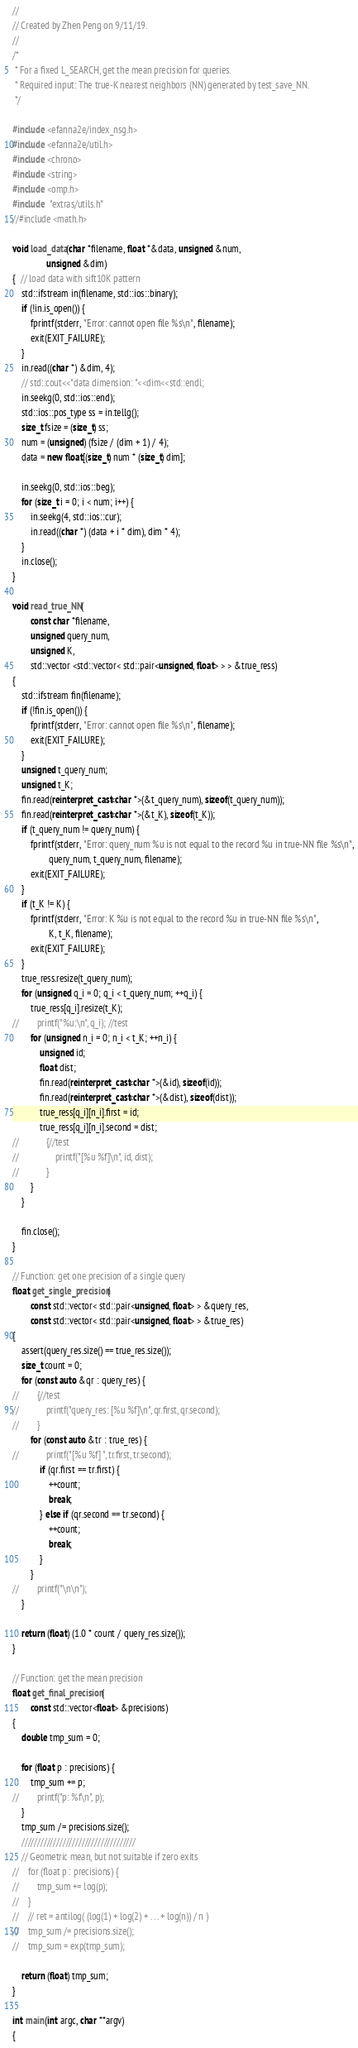<code> <loc_0><loc_0><loc_500><loc_500><_C++_>//
// Created by Zhen Peng on 9/11/19.
//
/*
 * For a fixed L_SEARCH, get the mean precision for queries.
 * Required input: The true-K nearest neighbors (NN) generated by test_save_NN.
 */

#include <efanna2e/index_nsg.h>
#include <efanna2e/util.h>
#include <chrono>
#include <string>
#include <omp.h>
#include  "extras/utils.h"
//#include <math.h>

void load_data(char *filename, float *&data, unsigned &num,
               unsigned &dim)
{  // load data with sift10K pattern
    std::ifstream in(filename, std::ios::binary);
    if (!in.is_open()) {
        fprintf(stderr, "Error: cannot open file %s\n", filename);
        exit(EXIT_FAILURE);
    }
    in.read((char *) &dim, 4);
    // std::cout<<"data dimension: "<<dim<<std::endl;
    in.seekg(0, std::ios::end);
    std::ios::pos_type ss = in.tellg();
    size_t fsize = (size_t) ss;
    num = (unsigned) (fsize / (dim + 1) / 4);
    data = new float[(size_t) num * (size_t) dim];

    in.seekg(0, std::ios::beg);
    for (size_t i = 0; i < num; i++) {
        in.seekg(4, std::ios::cur);
        in.read((char *) (data + i * dim), dim * 4);
    }
    in.close();
}

void read_true_NN(
        const char *filename,
        unsigned query_num,
        unsigned K,
        std::vector <std::vector< std::pair<unsigned, float> > > &true_ress)
{
    std::ifstream fin(filename);
    if (!fin.is_open()) {
        fprintf(stderr, "Error: cannot open file %s\n", filename);
        exit(EXIT_FAILURE);
    }
    unsigned t_query_num;
    unsigned t_K;
    fin.read(reinterpret_cast<char *>(&t_query_num), sizeof(t_query_num));
    fin.read(reinterpret_cast<char *>(&t_K), sizeof(t_K));
    if (t_query_num != query_num) {
        fprintf(stderr, "Error: query_num %u is not equal to the record %u in true-NN file %s\n",
                query_num, t_query_num, filename);
        exit(EXIT_FAILURE);
    }
    if (t_K != K) {
        fprintf(stderr, "Error: K %u is not equal to the record %u in true-NN file %s\n",
                K, t_K, filename);
        exit(EXIT_FAILURE);
    }
    true_ress.resize(t_query_num);
    for (unsigned q_i = 0; q_i < t_query_num; ++q_i) {
        true_ress[q_i].resize(t_K);
//        printf("%u:\n", q_i); //test
        for (unsigned n_i = 0; n_i < t_K; ++n_i) {
            unsigned id;
            float dist;
            fin.read(reinterpret_cast<char *>(&id), sizeof(id));
            fin.read(reinterpret_cast<char *>(&dist), sizeof(dist));
            true_ress[q_i][n_i].first = id;
            true_ress[q_i][n_i].second = dist;
//            {//test
//                printf("[%u %f]\n", id, dist);
//            }
        }
    }

    fin.close();
}

// Function: get one precision of a single query
float get_single_precision(
        const std::vector< std::pair<unsigned, float> > &query_res,
        const std::vector< std::pair<unsigned, float> > &true_res)
{
    assert(query_res.size() == true_res.size());
    size_t count = 0;
    for (const auto &qr : query_res) {
//        {//test
//            printf("query_res: [%u %f]\n", qr.first, qr.second);
//        }
        for (const auto &tr : true_res) {
//            printf("[%u %f] ", tr.first, tr.second);
            if (qr.first == tr.first) {
                ++count;
                break;
            } else if (qr.second == tr.second) {
                ++count;
                break;
            }
        }
//        printf("\n\n");
    }

    return (float) (1.0 * count / query_res.size());
}

// Function: get the mean precision
float get_final_precision(
        const std::vector<float> &precisions)
{
    double tmp_sum = 0;

    for (float p : precisions) {
        tmp_sum += p;
//        printf("p: %f\n", p);
    }
    tmp_sum /= precisions.size();
    ////////////////////////////////////
    // Geometric mean, but not suitable if zero exits
//    for (float p : precisions) {
//        tmp_sum += log(p);
//    }
//    // ret = antilog( (log(1) + log(2) + . . . + log(n)) / n )
//    tmp_sum /= precisions.size();
//    tmp_sum = exp(tmp_sum);

    return (float) tmp_sum;
}

int main(int argc, char **argv)
{</code> 